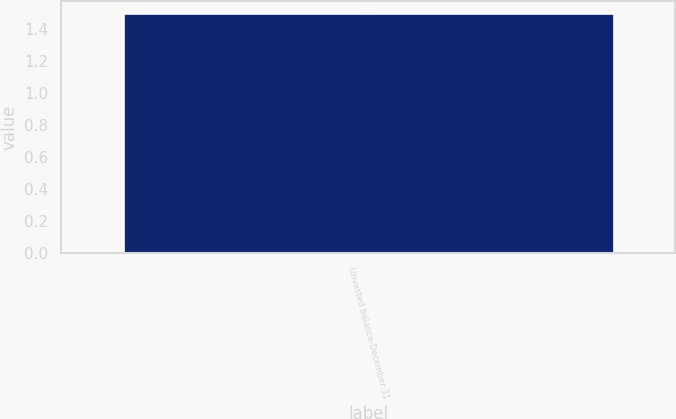Convert chart. <chart><loc_0><loc_0><loc_500><loc_500><bar_chart><fcel>Unvested balance-December 31<nl><fcel>1.5<nl></chart> 